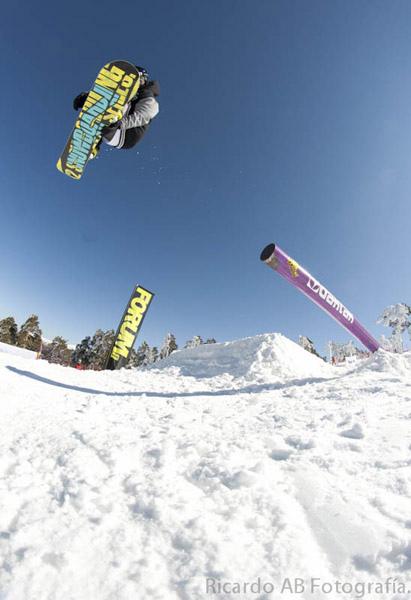Why isn't the snow melting?
Write a very short answer. Cold. Is the snowboarder jumping high?
Short answer required. Yes. What color is the snow?
Quick response, please. White. 